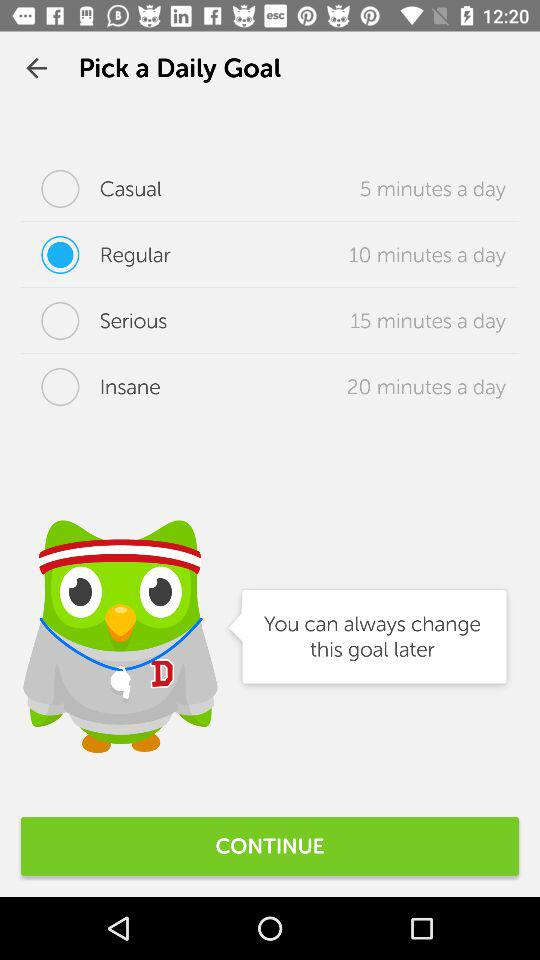What's the duration of the "Casual" daily goal? The duration is 5 minutes a day. 